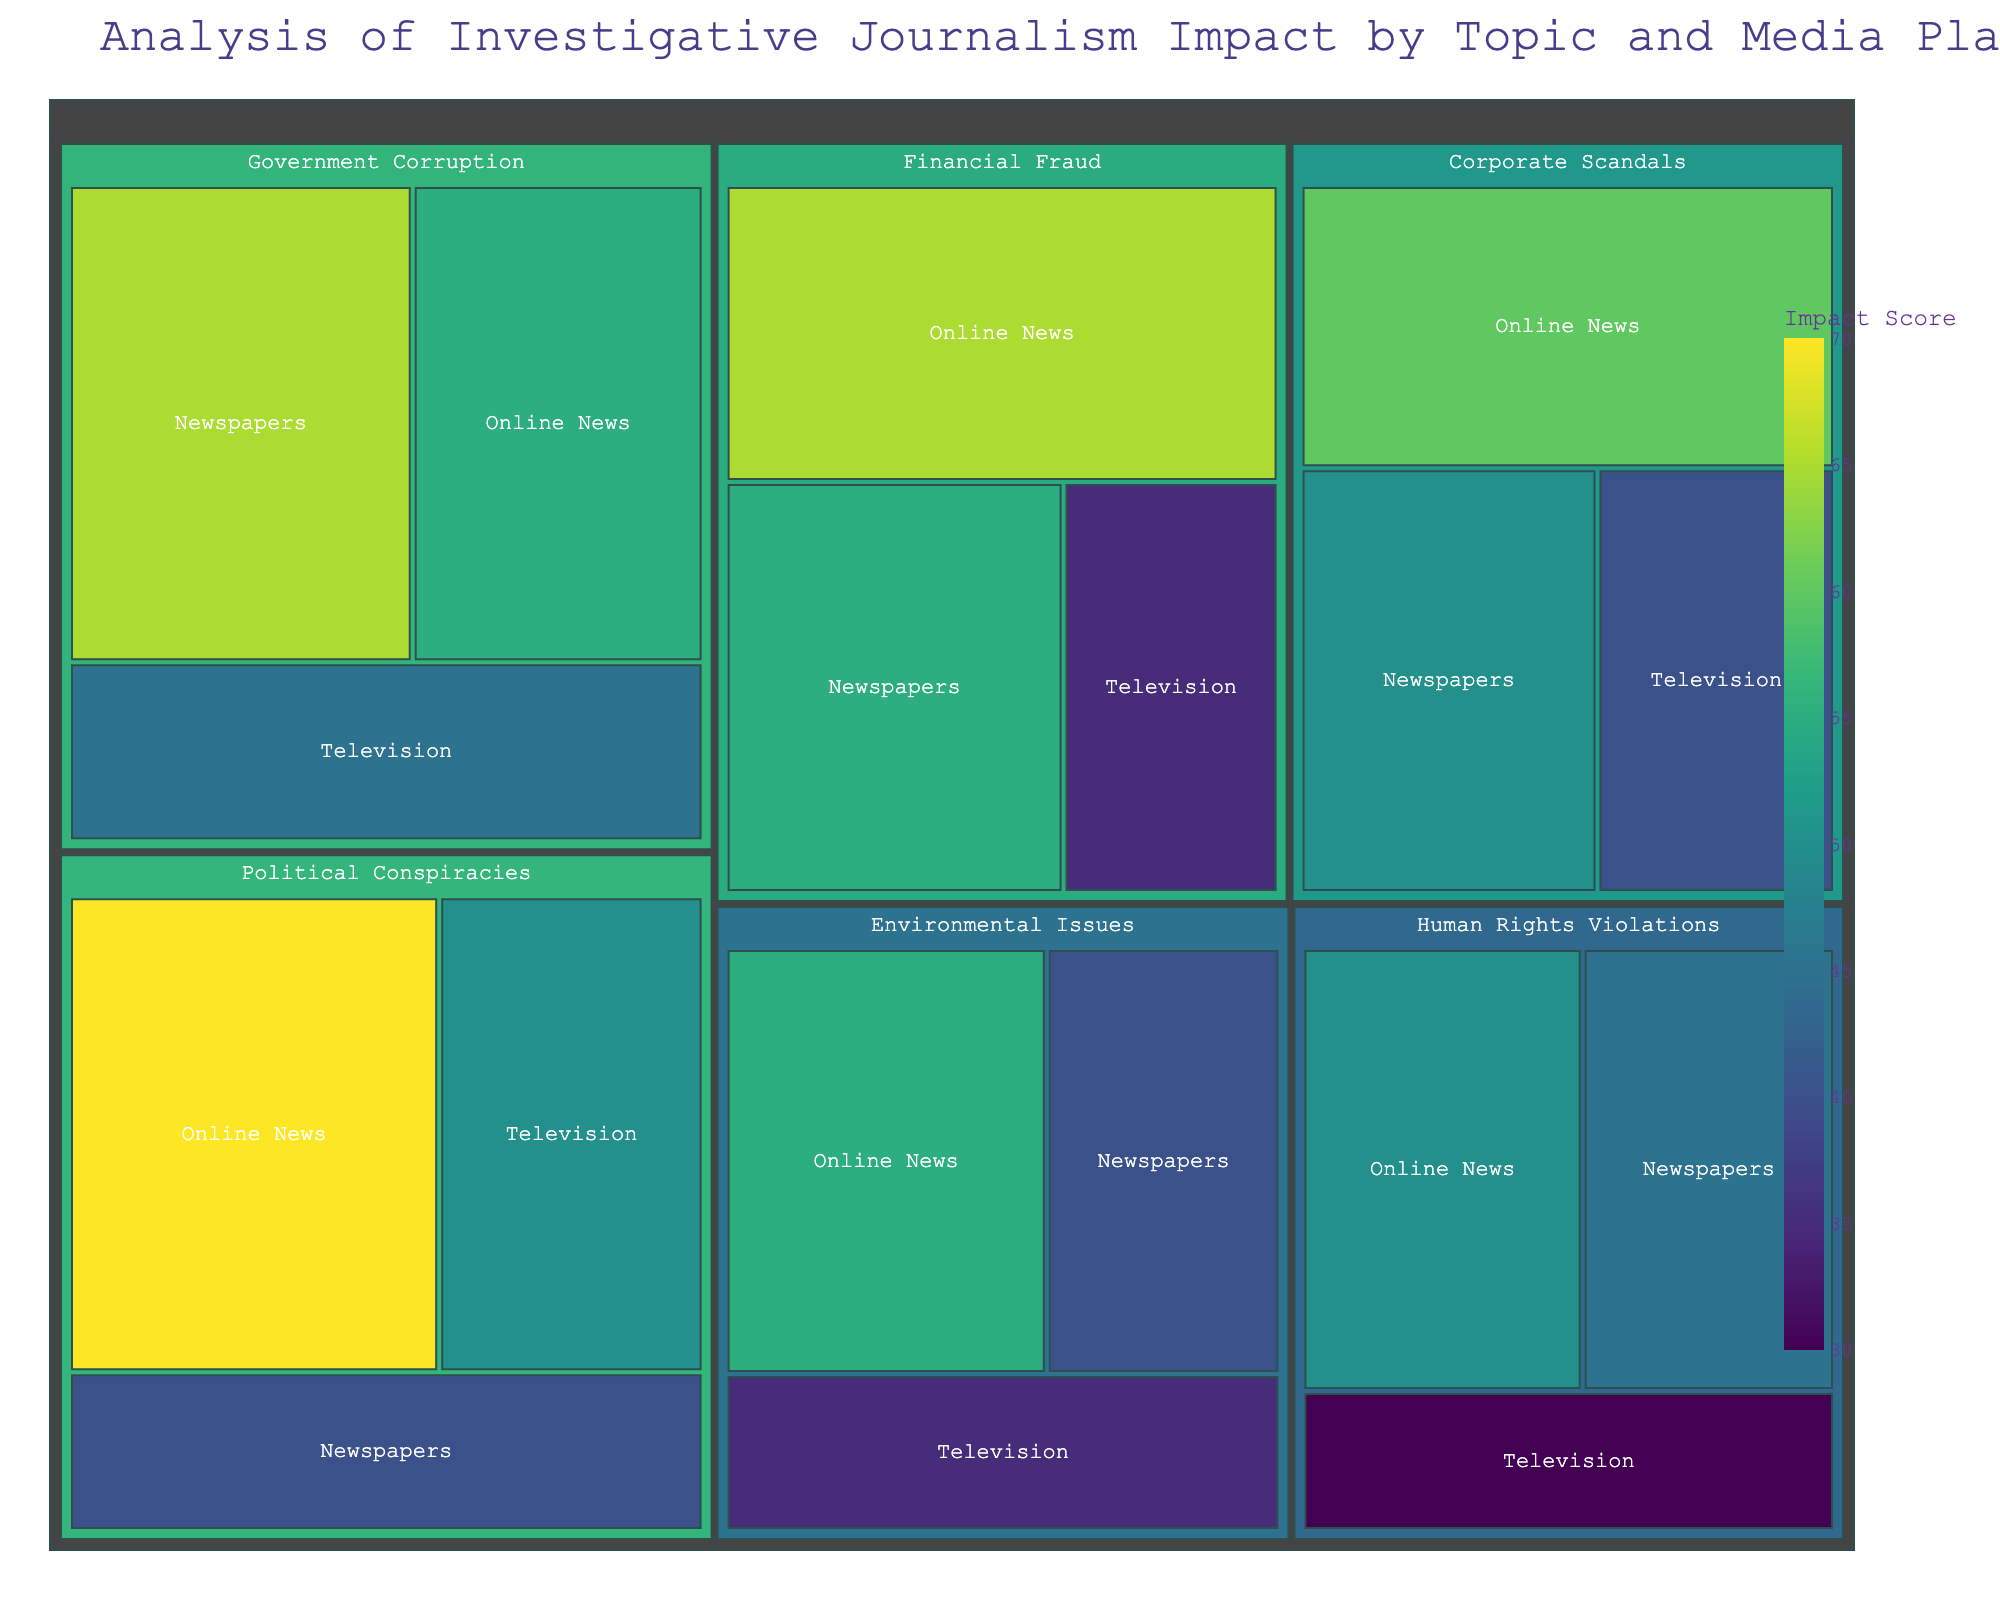What is the title of the Treemap figure? The title of the figure is shown at the top of the Treemap and describes the overall subject of the visualization.
Answer: Analysis of Investigative Journalism Impact by Topic and Media Platform Which topic has the highest impact score in Online News according to the Treemap? Locate the section of the Treemap where Online News is listed under each topic. Compare the impact scores for each topic in Online News.
Answer: Political Conspiracies What is the combined impact score of Government Corruption and Corporate Scandals in Newspapers? Find the sections for Government Corruption and Corporate Scandals under Newspapers, then sum their impact scores: 65 + 50.
Answer: 115 Compare the impact scores of Financial Fraud across different media platforms. Which platform shows the highest impact? Locate the sections for Financial Fraud in Newspapers, Online News, and Television. Compare their impact scores to determine the highest one.
Answer: Online News Among the topics listed, which one has the lowest impact score on Television? Look at the sections for each topic under Television and identify the lowest impact score among them.
Answer: Human Rights Violations Which topic has the smallest total impact score across all media platforms? Sum the impact scores for each topic across all platforms and determine the one with the smallest total.
Answer: Human Rights Violations What is the difference in impact score between Political Conspiracies in Online News and Financial Fraud in Television? Locate the impact scores for Political Conspiracies in Online News (70) and Financial Fraud in Television (35). Subtract the latter from the former: 70 - 35.
Answer: 35 What color scheme is used in the Treemap to represent varying impact scores? The color scheme can be identified via the color legend or the gradient colors used within the Treemap tiles based on their impact scores.
Answer: Viridis How do the impact scores for Environmental Issues on Online News and Television compare? Locate the segments for Environmental Issues in Online News and Television and compare their impact scores: 55 and 35 respectively.
Answer: Online News is higher Considering all platforms, which topic has the most balanced impact scores across Newspapers, Online News, and Television? Evaluate how similar the impact scores are for each topic across the three platforms. Look for the topic with the least variation.
Answer: Corporate Scandals 